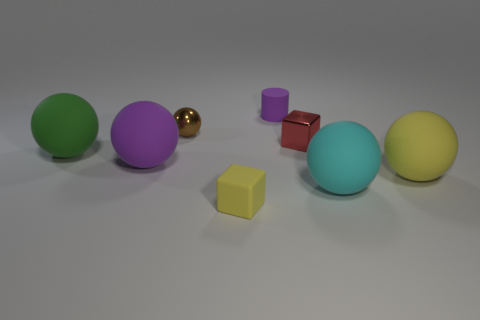Subtract all yellow matte spheres. How many spheres are left? 4 Subtract all brown balls. How many balls are left? 4 Add 1 red rubber cylinders. How many objects exist? 9 Subtract 1 cylinders. How many cylinders are left? 0 Subtract all red balls. How many red cubes are left? 1 Subtract all blocks. How many objects are left? 6 Subtract all gray cylinders. Subtract all purple cubes. How many cylinders are left? 1 Subtract all tiny gray rubber blocks. Subtract all cylinders. How many objects are left? 7 Add 5 small metallic cubes. How many small metallic cubes are left? 6 Add 6 large yellow matte spheres. How many large yellow matte spheres exist? 7 